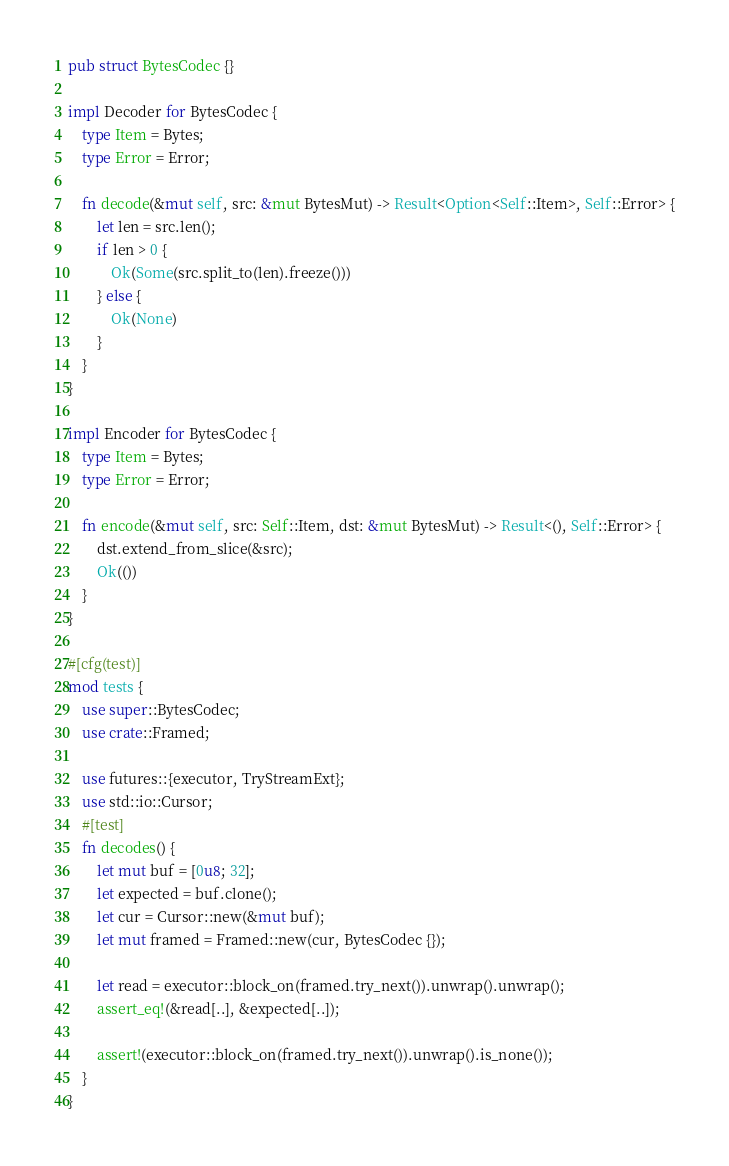Convert code to text. <code><loc_0><loc_0><loc_500><loc_500><_Rust_>pub struct BytesCodec {}

impl Decoder for BytesCodec {
    type Item = Bytes;
    type Error = Error;

    fn decode(&mut self, src: &mut BytesMut) -> Result<Option<Self::Item>, Self::Error> {
        let len = src.len();
        if len > 0 {
            Ok(Some(src.split_to(len).freeze()))
        } else {
            Ok(None)
        }
    }
}

impl Encoder for BytesCodec {
    type Item = Bytes;
    type Error = Error;

    fn encode(&mut self, src: Self::Item, dst: &mut BytesMut) -> Result<(), Self::Error> {
        dst.extend_from_slice(&src);
        Ok(())
    }
}

#[cfg(test)]
mod tests {
    use super::BytesCodec;
    use crate::Framed;

    use futures::{executor, TryStreamExt};
    use std::io::Cursor;
    #[test]
    fn decodes() {
        let mut buf = [0u8; 32];
        let expected = buf.clone();
        let cur = Cursor::new(&mut buf);
        let mut framed = Framed::new(cur, BytesCodec {});

        let read = executor::block_on(framed.try_next()).unwrap().unwrap();
        assert_eq!(&read[..], &expected[..]);

        assert!(executor::block_on(framed.try_next()).unwrap().is_none());
    }
}</code> 